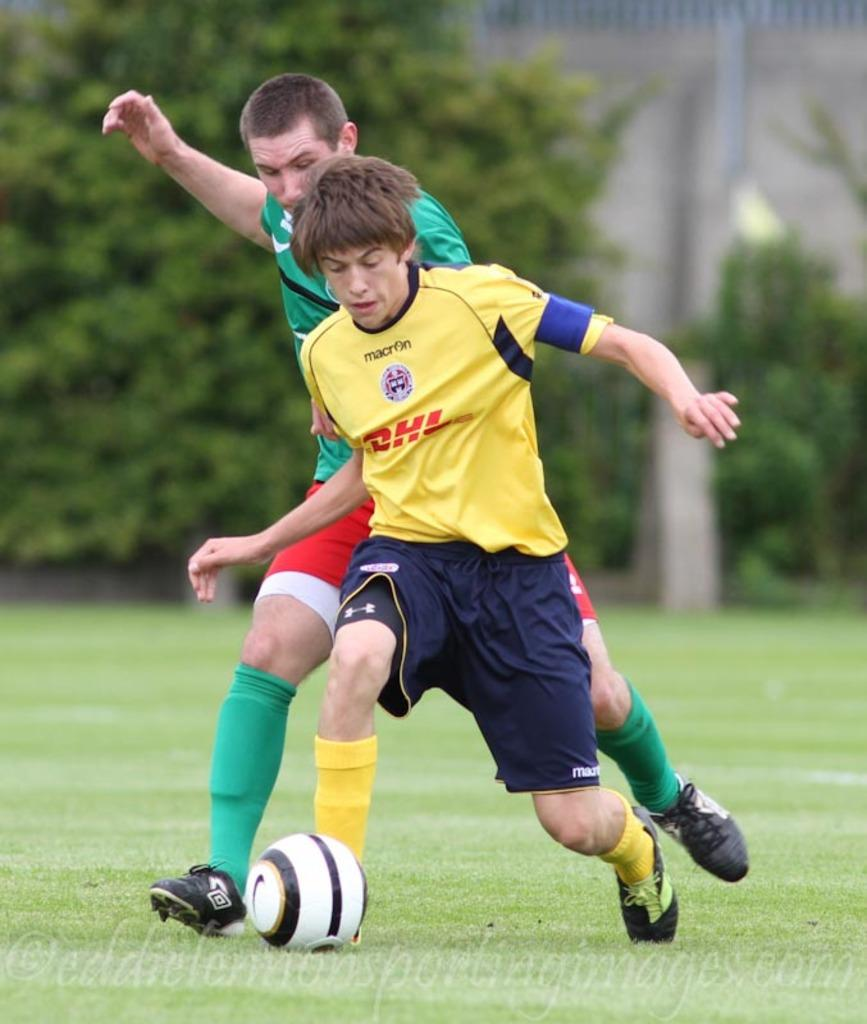How many people are in the image? There are two persons in the image. What are the persons doing in the image? The persons are playing with a ball. What can be seen in the background of the image? There are trees in the background of the image. Is there any text or marking at the bottom of the image? Yes, there is a watermark at the bottom of the image. What type of operation is being performed on the jellyfish in the image? There is no jellyfish or operation present in the image. 